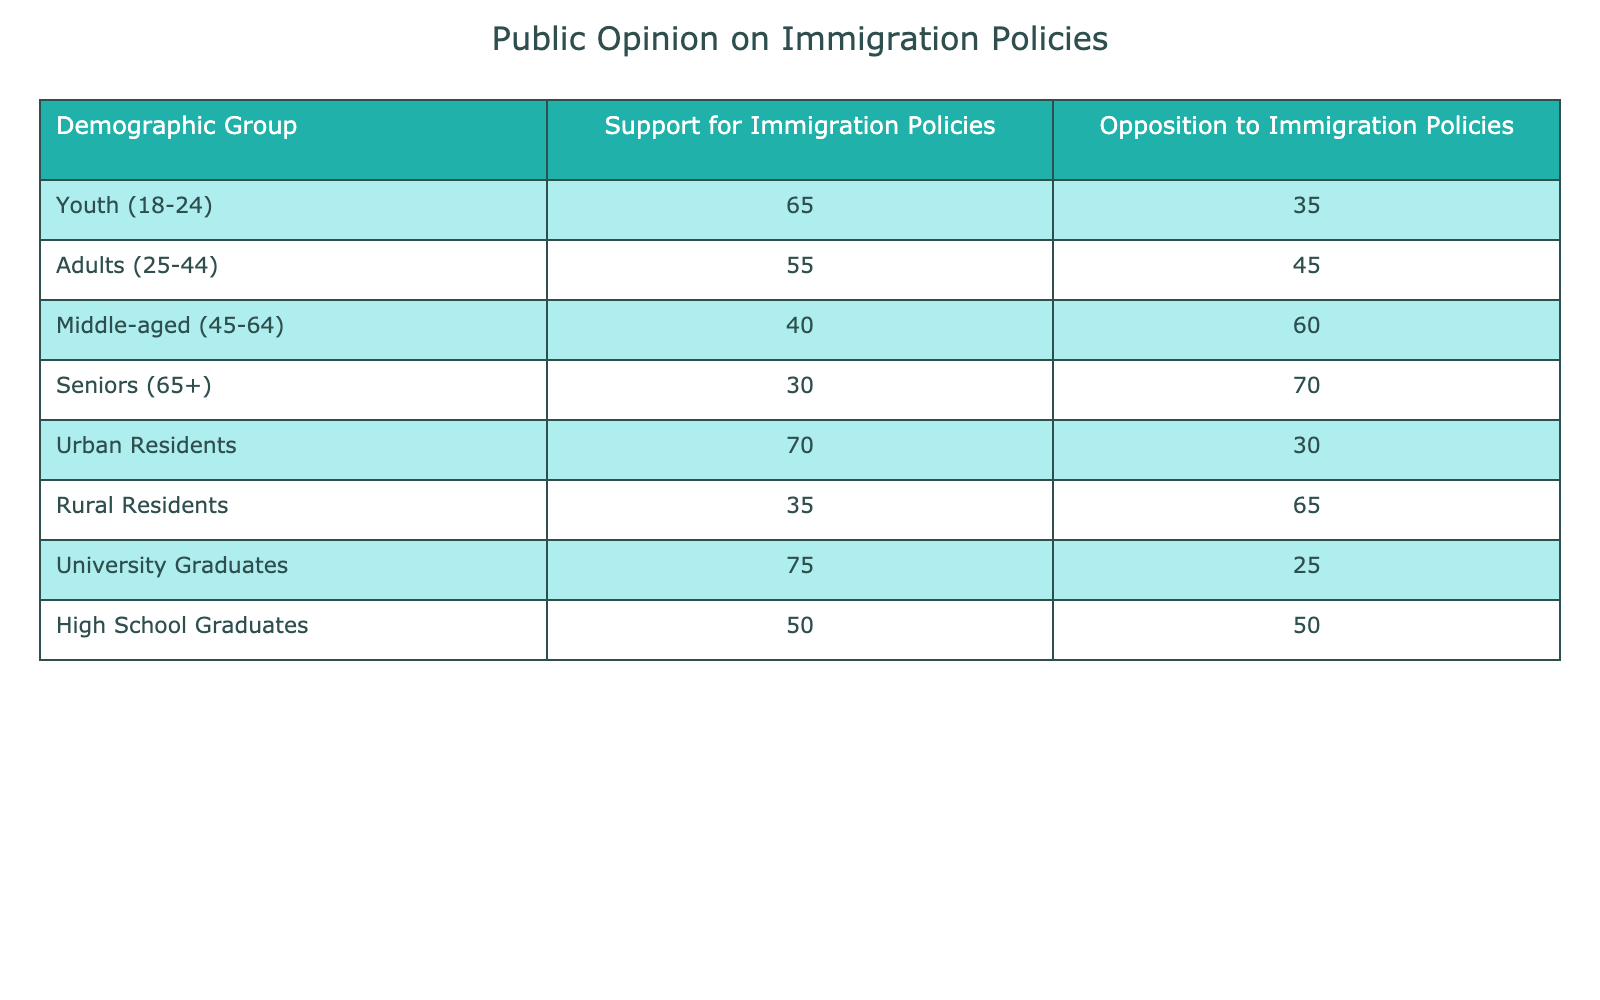What demographic group has the highest support for immigration policies? By examining the "Support for Immigration Policies" column, we see that "University Graduates" have the highest support, with a value of 75.
Answer: University Graduates What percentage of seniors oppose immigration policies? Looking at the "Opposition to Immigration Policies" column, "Seniors (65+)" have an opposition value of 70, indicating that 70% of them oppose immigration policies.
Answer: 70% What is the difference in support for immigration policies between urban and rural residents? The support for "Urban Residents" is 70, while for "Rural Residents" it is 35. The difference is 70 - 35 = 35.
Answer: 35 Is the support for immigration policies among middle-aged individuals greater than that among seniors? "Middle-aged (45-64)" support is 40, and "Seniors (65+)" support is 30. Since 40 is greater than 30, the statement is true.
Answer: Yes What is the average support for immigration policies among the youth and adults? The support values for "Youth (18-24)" is 65 and for "Adults (25-44)" is 55. The average is calculated as (65 + 55) / 2 = 60.
Answer: 60 What demographic group has the lowest support for immigration policies? Reviewing the "Support for Immigration Policies" column, "Seniors (65+)" have the lowest support, with a value of 30.
Answer: Seniors (65+) Are university graduates more supportive of immigration policies than adults? "University Graduates" have a support value of 75, while "Adults (25-44)" have a value of 55. Since 75 is greater than 55, the answer is yes.
Answer: Yes What is the total support for immigration policies from all demographic groups? The total support is calculated by summing values: 65 + 55 + 40 + 30 + 70 + 35 + 75 + 50 = 420.
Answer: 420 What proportion of high school graduates oppose immigration policies? The "Opposition to Immigration Policies" for "High School Graduates" is 50. To find the proportion, we compare this to the total (50 opposed and 50 supported). Thus, the proportion is 50/100 = 0.5, or 50%.
Answer: 50% 